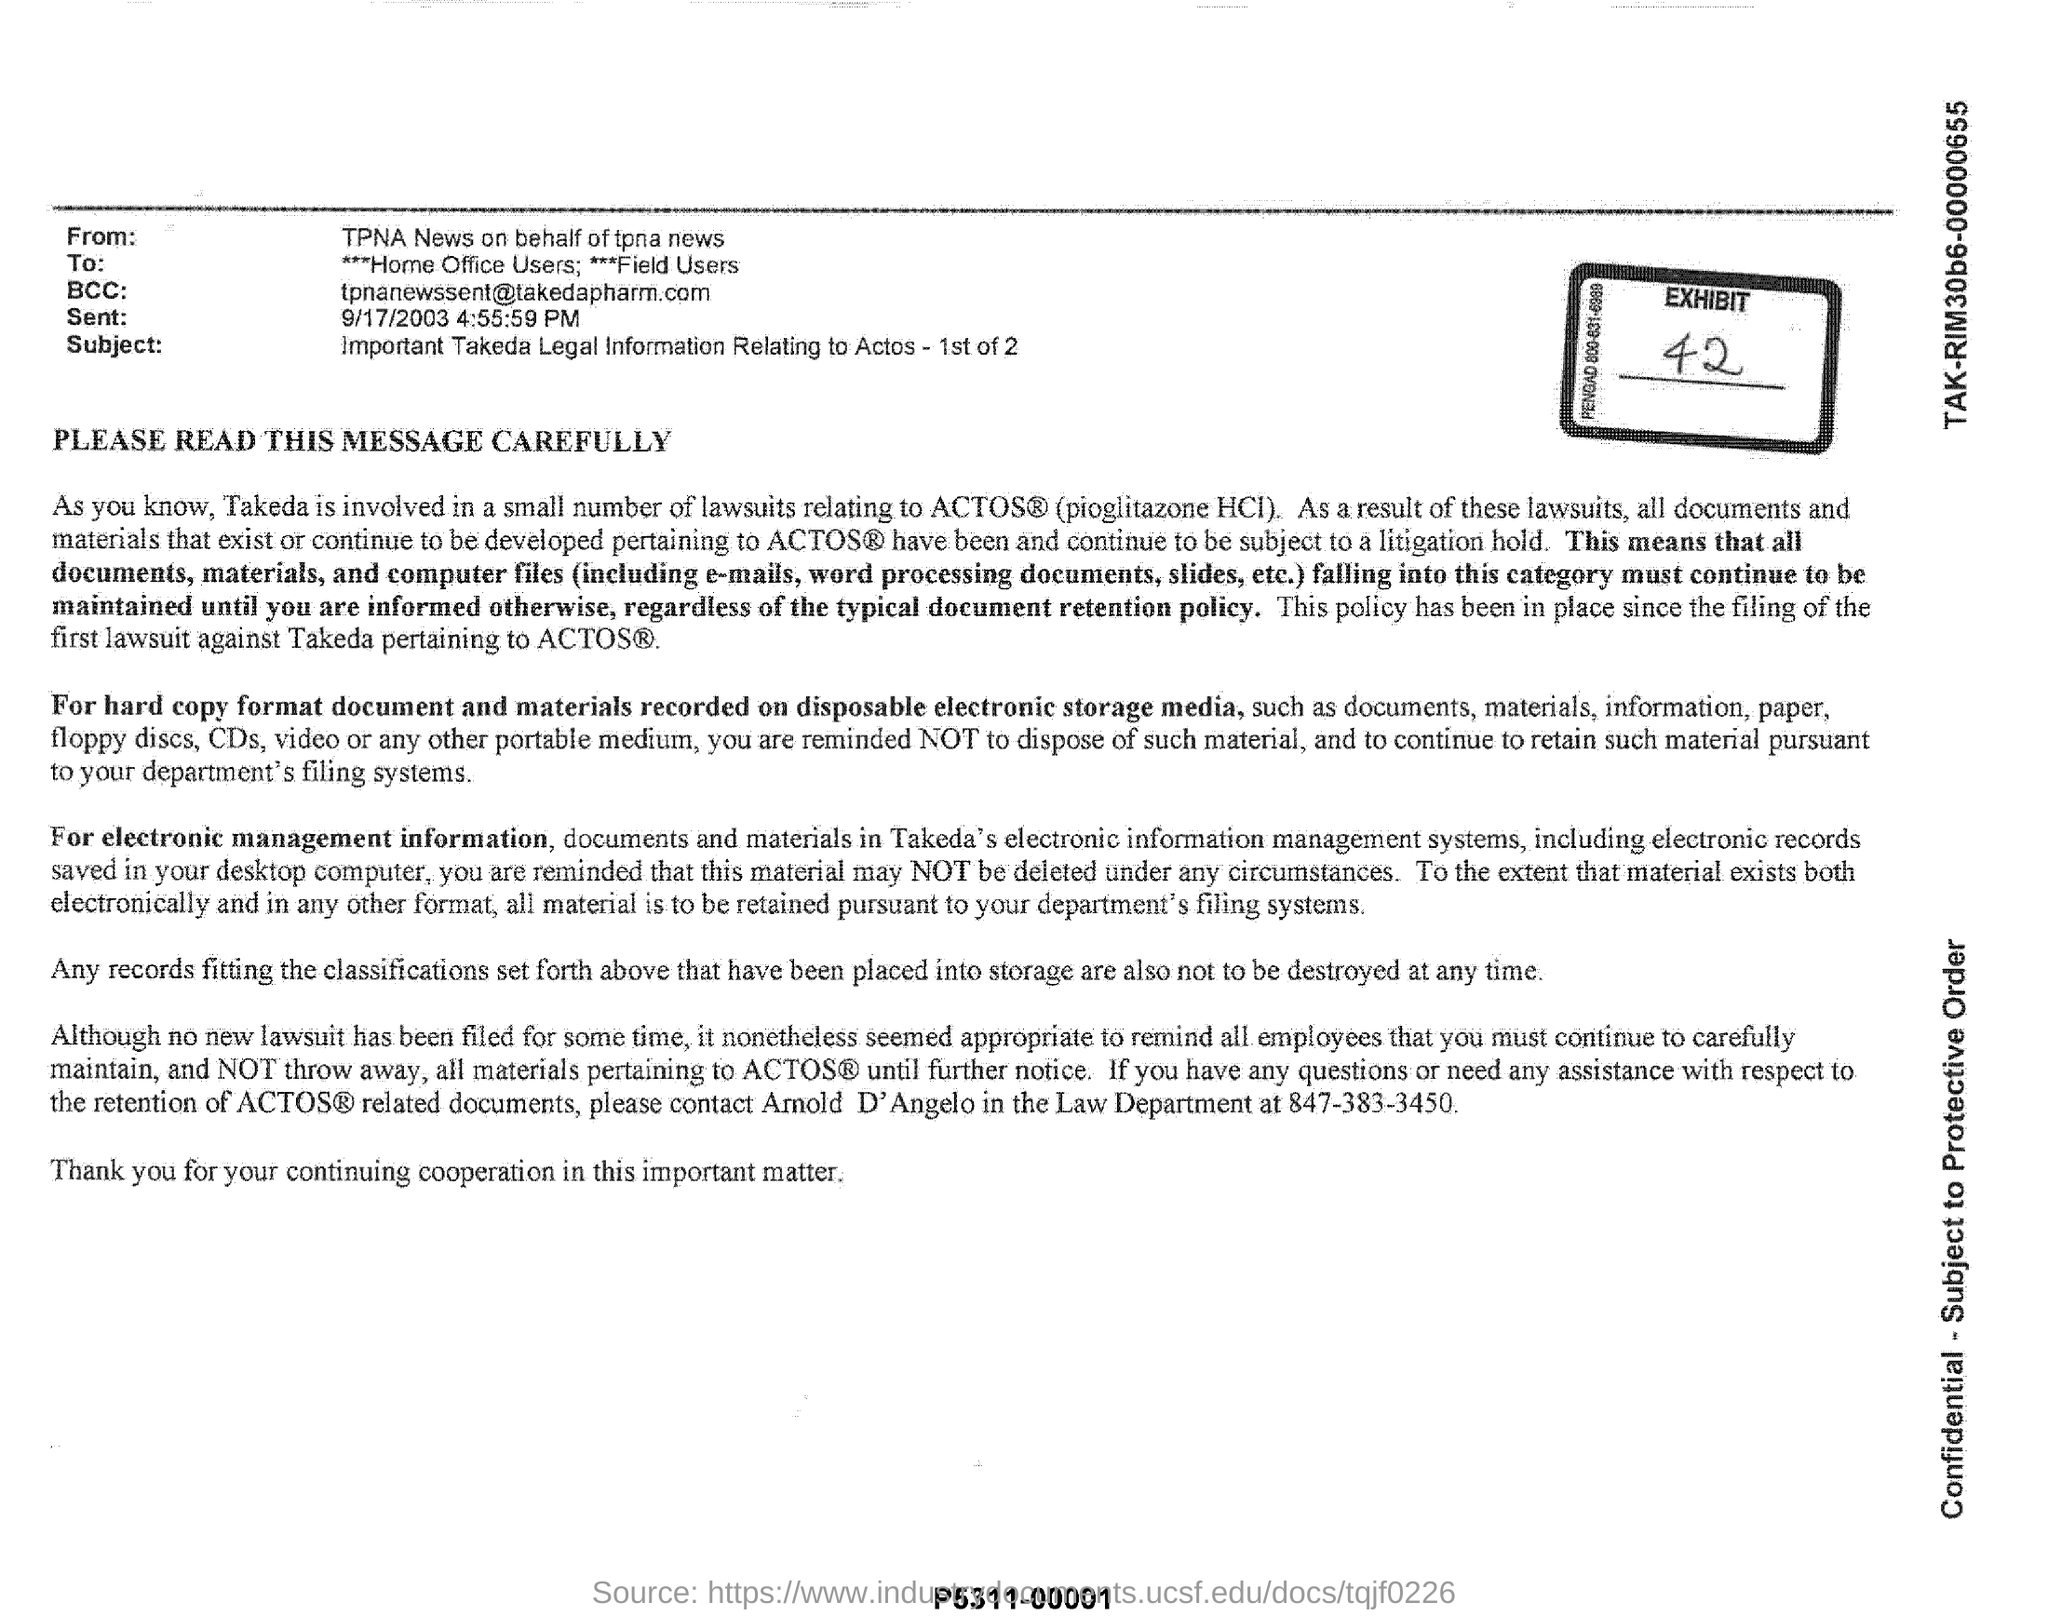Identify some key points in this picture. The subject of this email is the important legal information regarding Actos, which is being provided in two parts. This document is from tpna news, who is acting on behalf of tpna news. The sender of this email is TPNA News on behalf of TPNA News. 